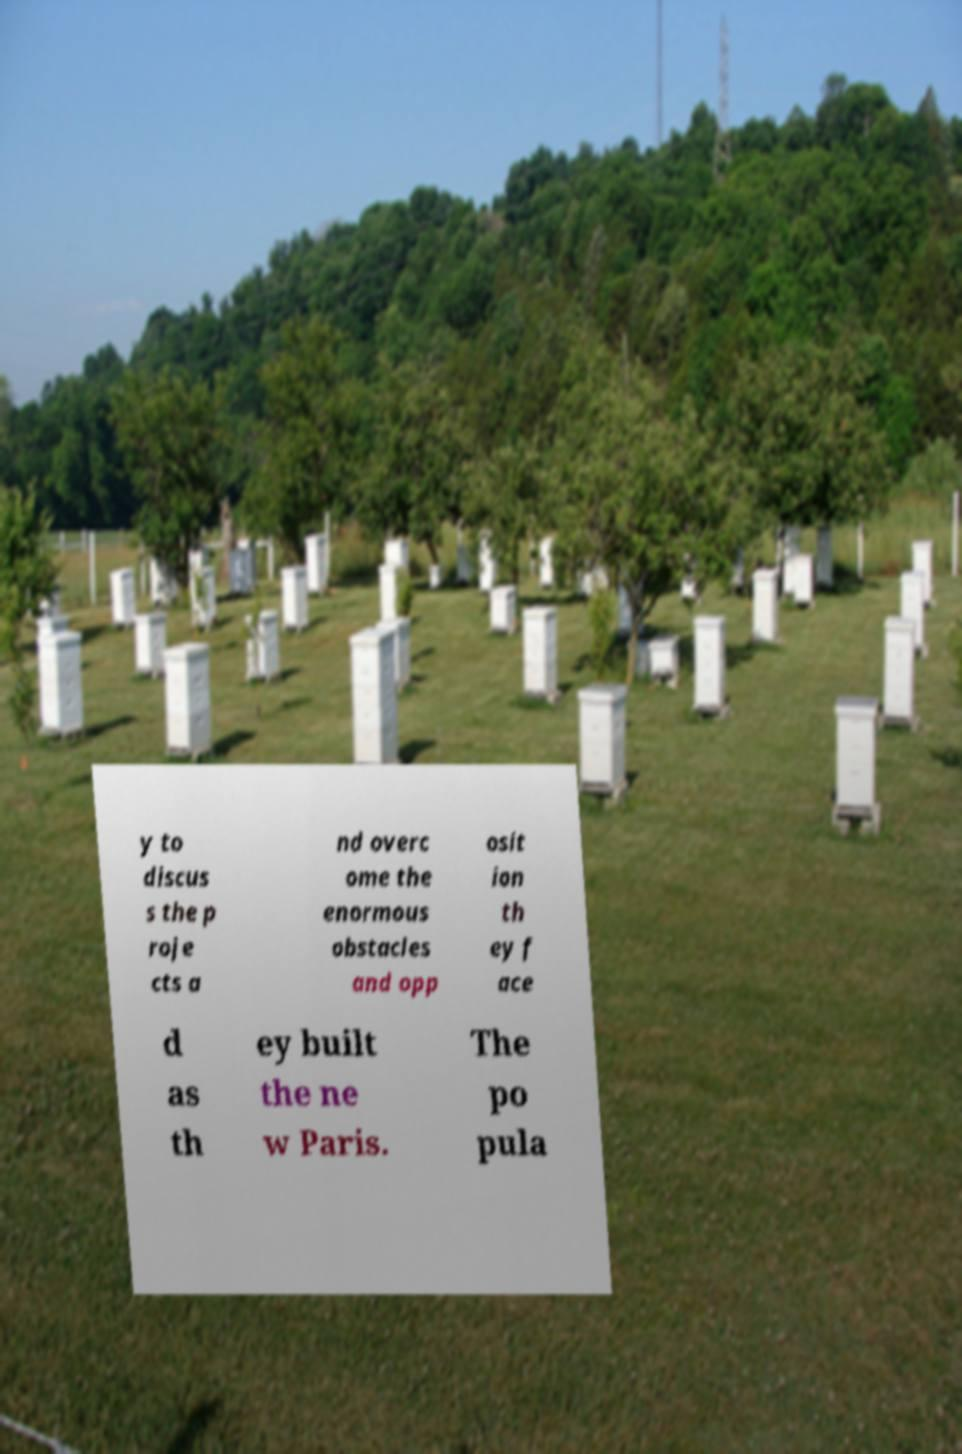Can you accurately transcribe the text from the provided image for me? y to discus s the p roje cts a nd overc ome the enormous obstacles and opp osit ion th ey f ace d as th ey built the ne w Paris. The po pula 